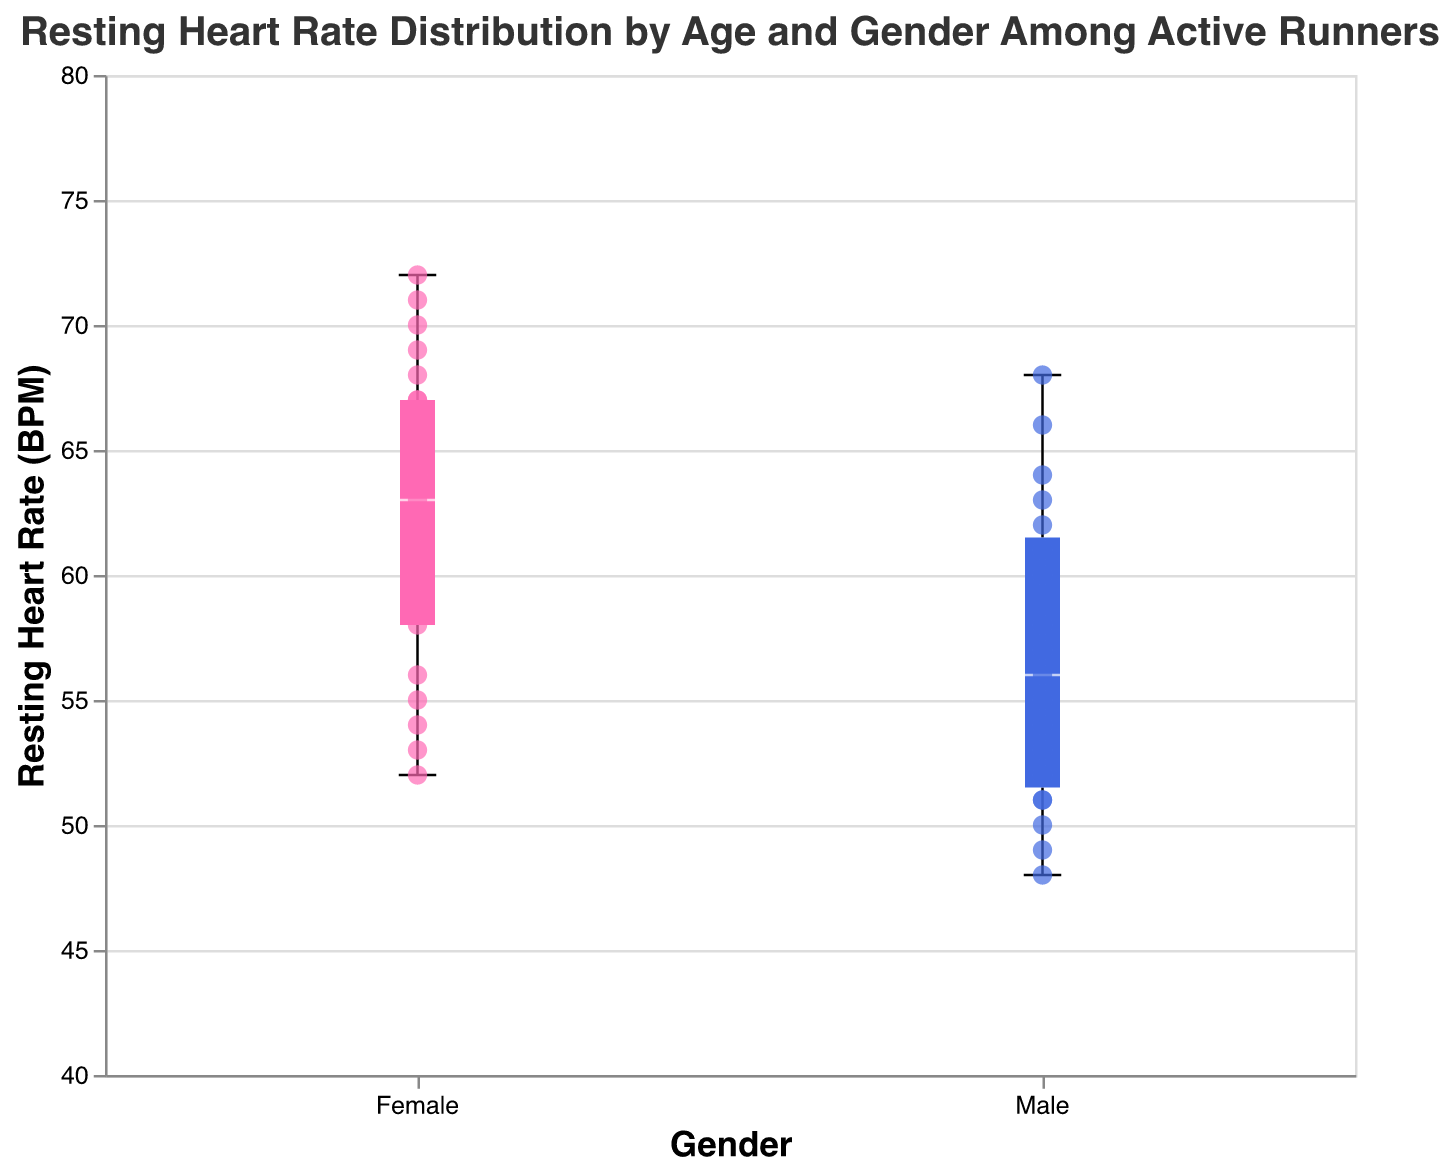What is the title of the figure? The title is displayed at the top of the chart and summarizes what the figure represents.
Answer: Resting Heart Rate Distribution by Age and Gender Among Active Runners What are the two categories on the x-axis? The x-axis represents categorical data which shows the two distinct genders in the dataset.
Answer: Male and Female What is the range of resting heart rates on the y-axis? By examining the y-axis, we can see the minimum and maximum values that it covers. The axis scale starts at 45 BPM and ends at 75 BPM, which frames the data points and box plots.
Answer: 45 to 75 BPM Which gender has a lower median resting heart rate? The box plot median is indicated by a white line inside the box. Comparing the two boxes, the male category has a lower median line position than the female category.
Answer: Male How many scatter points are there for females? Each dot represents an individual data point. By counting the scatter points on the female side, we obtain the total number of data points available for females.
Answer: 21 What is the resting heart rate value of the highest data point for males? The highest data point can be identified by looking for the top-most scatter point in the male category. The male with the highest resting heart rate has a value of 68 BPM.
Answer: 68 BPM Which gender has more variability in their resting heart rate? Variability can be observed through the length of the box and whiskers in the box plot. The female category has a wider range, showing greater variability.
Answer: Female What's the difference in the median resting heart rate between males and females? The median values can be read from the positions of the white lines inside the boxes. Subtract the median value for males from the median value for females to find the difference.
Answer: 8 BPM (Female median higher) What is the interquartile range (IQR) for females? The IQR represents the range between the first quartile (bottom line of the box) and the third quartile (top line of the box). For females, the resting heart rates at these positions are approximately 58 and 67 BPM. The IQR is calculated by subtracting the first quartile from the third quartile.
Answer: 9 BPM Is there an age-related trend in the scatter points for either gender? Observing the scatter points, we look for patterns where the resting heart rate tends to increase or decrease with age for either gender.
Answer: Yes, there appears to be an upwards trend for both genders 